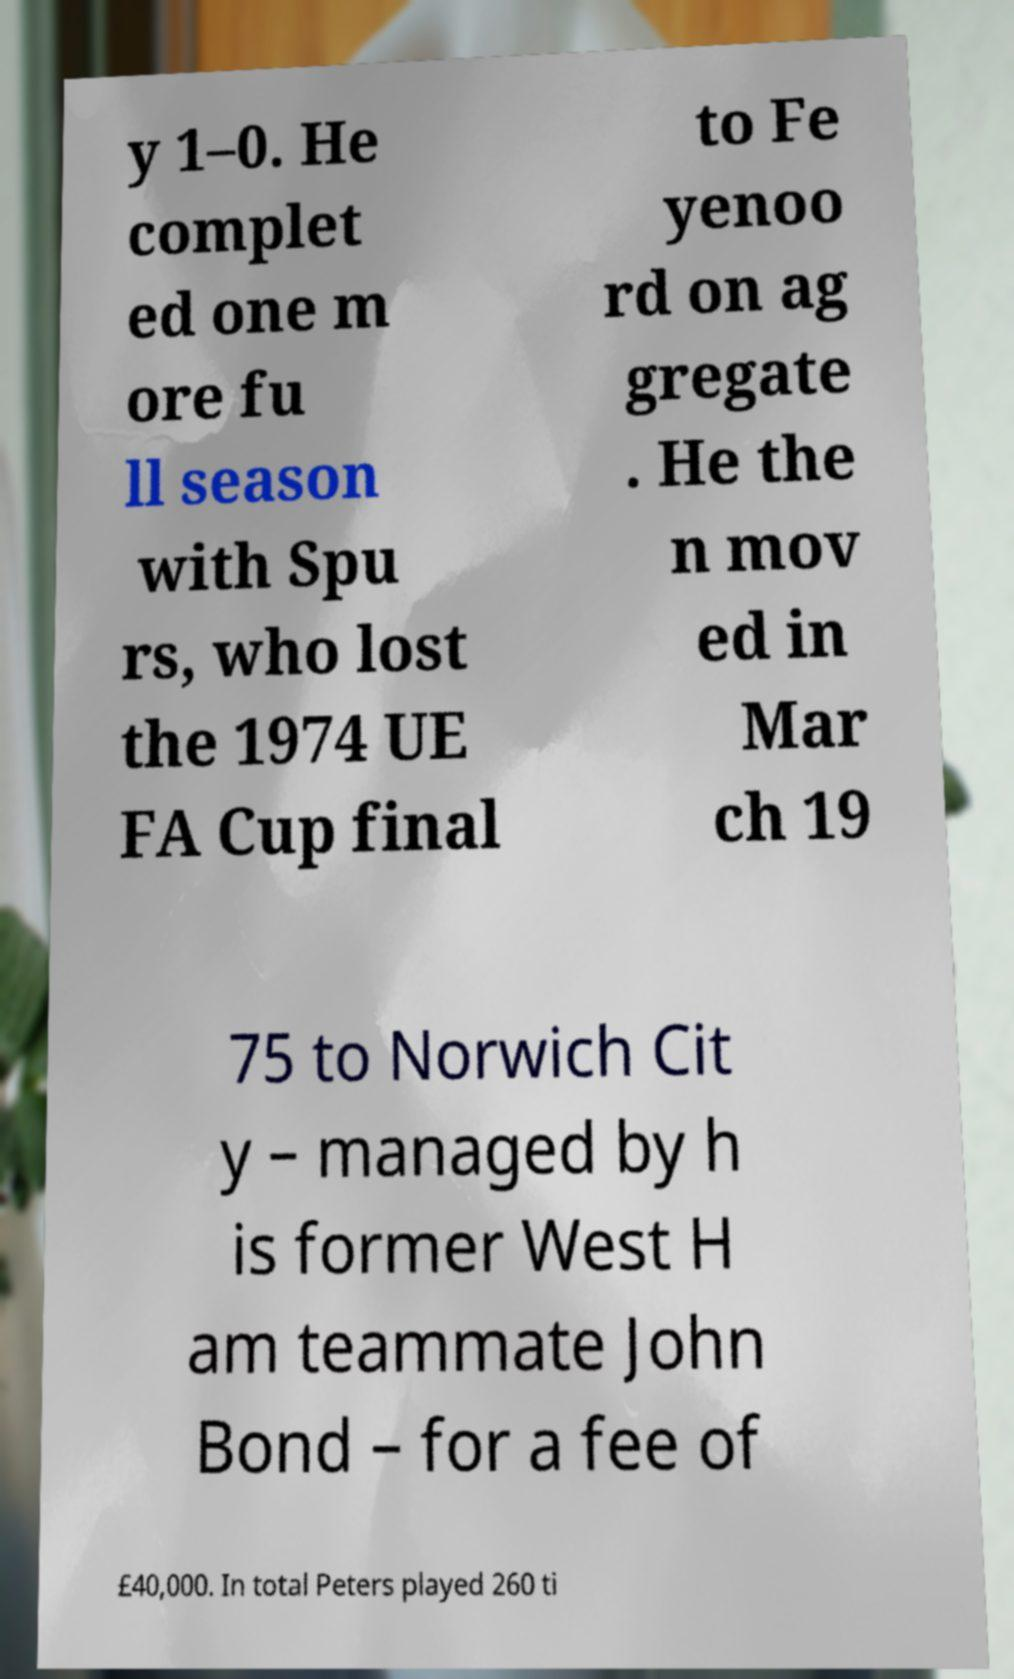What messages or text are displayed in this image? I need them in a readable, typed format. y 1–0. He complet ed one m ore fu ll season with Spu rs, who lost the 1974 UE FA Cup final to Fe yenoo rd on ag gregate . He the n mov ed in Mar ch 19 75 to Norwich Cit y – managed by h is former West H am teammate John Bond – for a fee of £40,000. In total Peters played 260 ti 